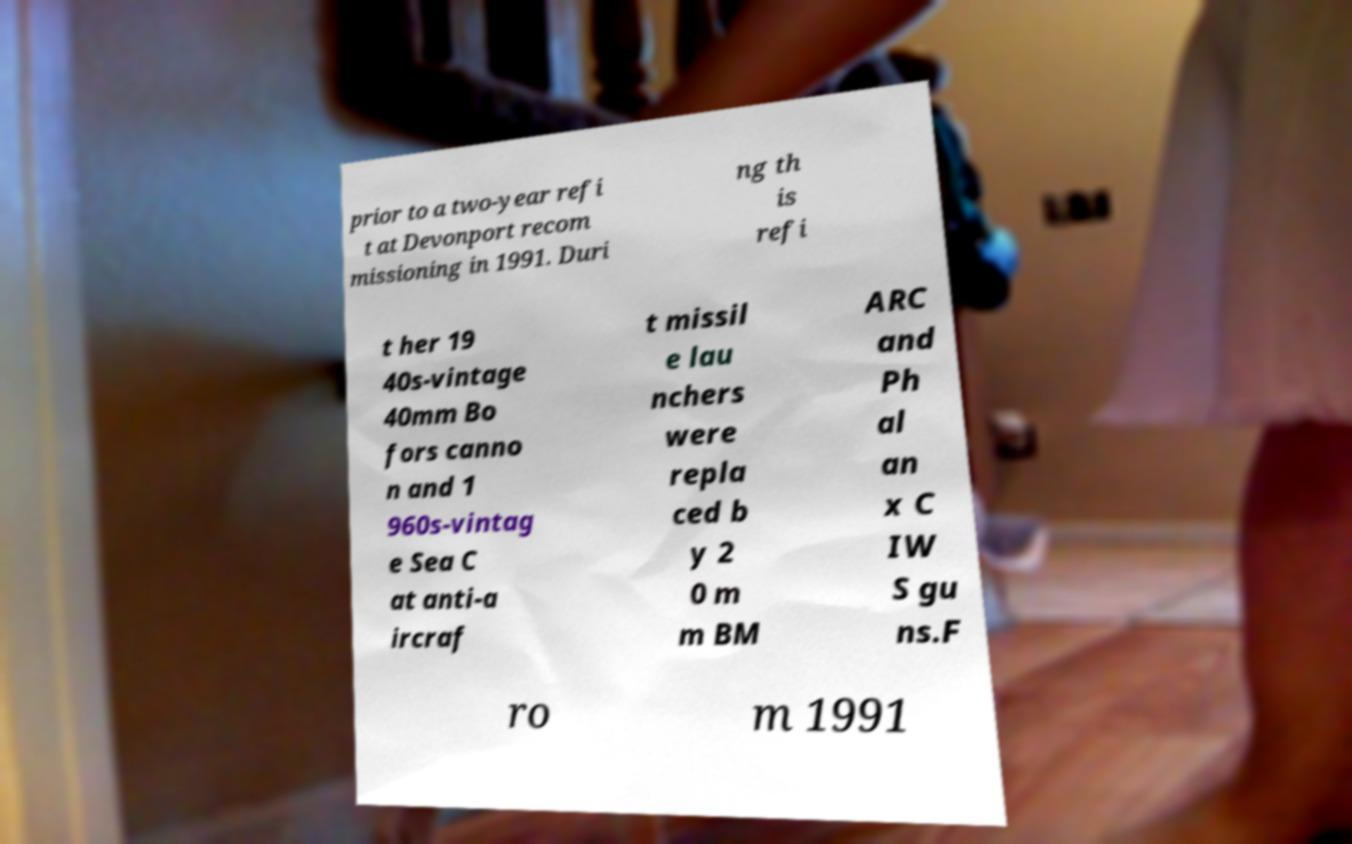Please identify and transcribe the text found in this image. prior to a two-year refi t at Devonport recom missioning in 1991. Duri ng th is refi t her 19 40s-vintage 40mm Bo fors canno n and 1 960s-vintag e Sea C at anti-a ircraf t missil e lau nchers were repla ced b y 2 0 m m BM ARC and Ph al an x C IW S gu ns.F ro m 1991 